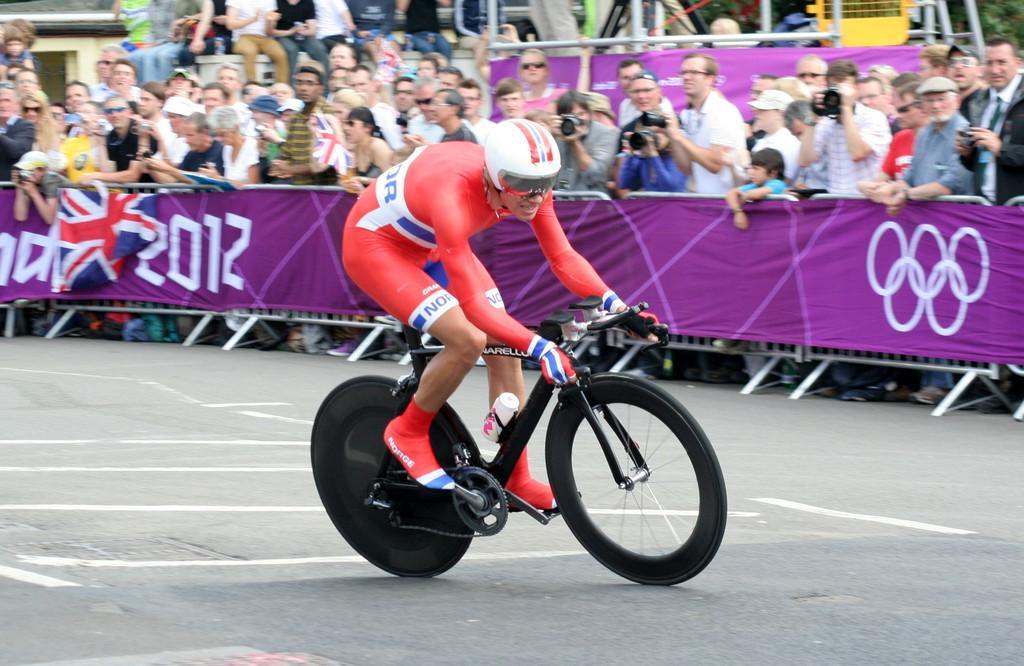Please provide a concise description of this image. In this image in the foreground I can see a person riding bicycle and wearing a helmet and in the background there are many people standing and some of them are talking pictures. 